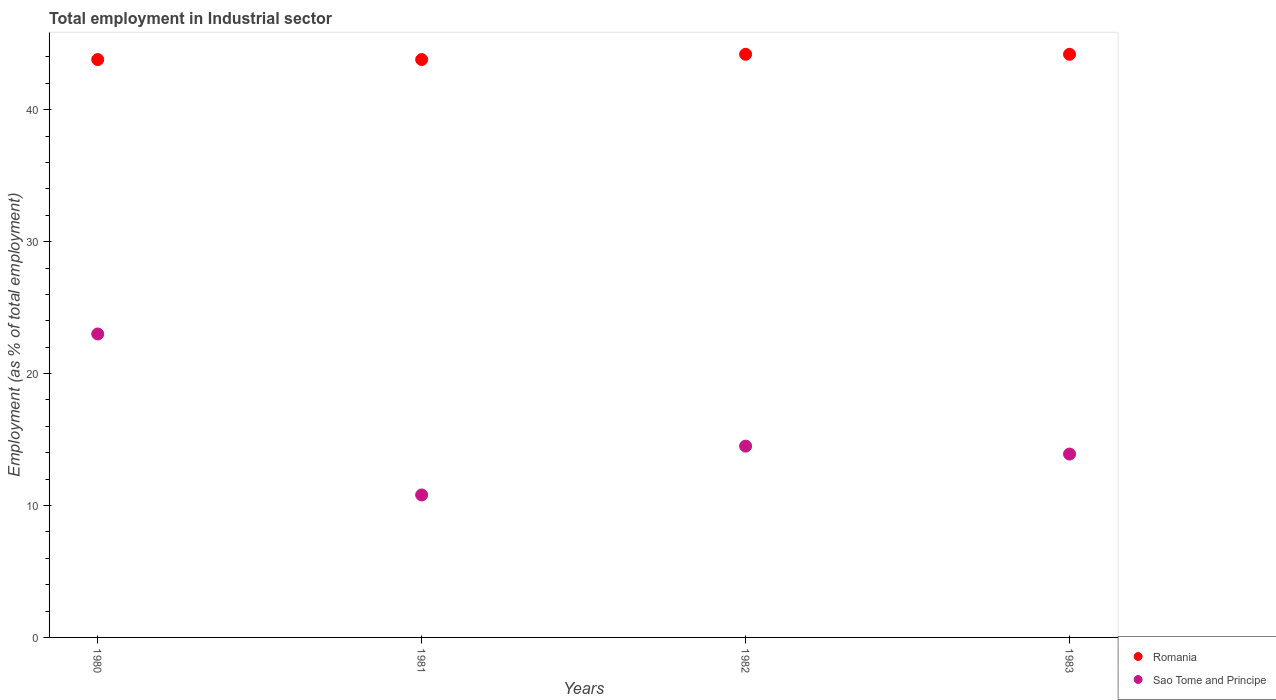Is the number of dotlines equal to the number of legend labels?
Ensure brevity in your answer.  Yes. What is the employment in industrial sector in Romania in 1983?
Provide a short and direct response. 44.2. Across all years, what is the maximum employment in industrial sector in Romania?
Your response must be concise. 44.2. Across all years, what is the minimum employment in industrial sector in Sao Tome and Principe?
Give a very brief answer. 10.8. In which year was the employment in industrial sector in Sao Tome and Principe minimum?
Offer a terse response. 1981. What is the total employment in industrial sector in Romania in the graph?
Your answer should be compact. 176. What is the difference between the employment in industrial sector in Romania in 1980 and that in 1981?
Provide a succinct answer. 0. What is the difference between the employment in industrial sector in Sao Tome and Principe in 1980 and the employment in industrial sector in Romania in 1982?
Provide a succinct answer. -21.2. What is the average employment in industrial sector in Romania per year?
Make the answer very short. 44. In the year 1983, what is the difference between the employment in industrial sector in Sao Tome and Principe and employment in industrial sector in Romania?
Provide a succinct answer. -30.3. In how many years, is the employment in industrial sector in Sao Tome and Principe greater than 8 %?
Provide a succinct answer. 4. What is the ratio of the employment in industrial sector in Romania in 1981 to that in 1983?
Your answer should be very brief. 0.99. What is the difference between the highest and the second highest employment in industrial sector in Romania?
Make the answer very short. 0. What is the difference between the highest and the lowest employment in industrial sector in Sao Tome and Principe?
Give a very brief answer. 12.2. In how many years, is the employment in industrial sector in Romania greater than the average employment in industrial sector in Romania taken over all years?
Provide a short and direct response. 2. Does the employment in industrial sector in Sao Tome and Principe monotonically increase over the years?
Ensure brevity in your answer.  No. Is the employment in industrial sector in Sao Tome and Principe strictly greater than the employment in industrial sector in Romania over the years?
Your answer should be very brief. No. How many years are there in the graph?
Your answer should be very brief. 4. Are the values on the major ticks of Y-axis written in scientific E-notation?
Keep it short and to the point. No. Does the graph contain grids?
Your answer should be very brief. No. How are the legend labels stacked?
Provide a short and direct response. Vertical. What is the title of the graph?
Your answer should be compact. Total employment in Industrial sector. Does "Europe(all income levels)" appear as one of the legend labels in the graph?
Ensure brevity in your answer.  No. What is the label or title of the Y-axis?
Give a very brief answer. Employment (as % of total employment). What is the Employment (as % of total employment) of Romania in 1980?
Keep it short and to the point. 43.8. What is the Employment (as % of total employment) in Sao Tome and Principe in 1980?
Give a very brief answer. 23. What is the Employment (as % of total employment) in Romania in 1981?
Your answer should be very brief. 43.8. What is the Employment (as % of total employment) in Sao Tome and Principe in 1981?
Make the answer very short. 10.8. What is the Employment (as % of total employment) of Romania in 1982?
Provide a succinct answer. 44.2. What is the Employment (as % of total employment) of Sao Tome and Principe in 1982?
Provide a succinct answer. 14.5. What is the Employment (as % of total employment) of Romania in 1983?
Your answer should be compact. 44.2. What is the Employment (as % of total employment) in Sao Tome and Principe in 1983?
Keep it short and to the point. 13.9. Across all years, what is the maximum Employment (as % of total employment) of Romania?
Provide a short and direct response. 44.2. Across all years, what is the minimum Employment (as % of total employment) in Romania?
Provide a short and direct response. 43.8. Across all years, what is the minimum Employment (as % of total employment) in Sao Tome and Principe?
Your answer should be compact. 10.8. What is the total Employment (as % of total employment) of Romania in the graph?
Your answer should be very brief. 176. What is the total Employment (as % of total employment) in Sao Tome and Principe in the graph?
Provide a short and direct response. 62.2. What is the difference between the Employment (as % of total employment) of Romania in 1980 and that in 1982?
Give a very brief answer. -0.4. What is the difference between the Employment (as % of total employment) of Sao Tome and Principe in 1980 and that in 1982?
Offer a terse response. 8.5. What is the difference between the Employment (as % of total employment) of Romania in 1980 and that in 1983?
Make the answer very short. -0.4. What is the difference between the Employment (as % of total employment) of Sao Tome and Principe in 1981 and that in 1983?
Provide a short and direct response. -3.1. What is the difference between the Employment (as % of total employment) in Romania in 1980 and the Employment (as % of total employment) in Sao Tome and Principe in 1981?
Provide a short and direct response. 33. What is the difference between the Employment (as % of total employment) in Romania in 1980 and the Employment (as % of total employment) in Sao Tome and Principe in 1982?
Provide a succinct answer. 29.3. What is the difference between the Employment (as % of total employment) of Romania in 1980 and the Employment (as % of total employment) of Sao Tome and Principe in 1983?
Provide a short and direct response. 29.9. What is the difference between the Employment (as % of total employment) of Romania in 1981 and the Employment (as % of total employment) of Sao Tome and Principe in 1982?
Offer a very short reply. 29.3. What is the difference between the Employment (as % of total employment) of Romania in 1981 and the Employment (as % of total employment) of Sao Tome and Principe in 1983?
Your answer should be very brief. 29.9. What is the difference between the Employment (as % of total employment) of Romania in 1982 and the Employment (as % of total employment) of Sao Tome and Principe in 1983?
Your answer should be compact. 30.3. What is the average Employment (as % of total employment) of Romania per year?
Keep it short and to the point. 44. What is the average Employment (as % of total employment) of Sao Tome and Principe per year?
Your answer should be very brief. 15.55. In the year 1980, what is the difference between the Employment (as % of total employment) in Romania and Employment (as % of total employment) in Sao Tome and Principe?
Offer a terse response. 20.8. In the year 1981, what is the difference between the Employment (as % of total employment) in Romania and Employment (as % of total employment) in Sao Tome and Principe?
Ensure brevity in your answer.  33. In the year 1982, what is the difference between the Employment (as % of total employment) in Romania and Employment (as % of total employment) in Sao Tome and Principe?
Offer a very short reply. 29.7. In the year 1983, what is the difference between the Employment (as % of total employment) of Romania and Employment (as % of total employment) of Sao Tome and Principe?
Offer a terse response. 30.3. What is the ratio of the Employment (as % of total employment) in Sao Tome and Principe in 1980 to that in 1981?
Offer a very short reply. 2.13. What is the ratio of the Employment (as % of total employment) of Sao Tome and Principe in 1980 to that in 1982?
Offer a terse response. 1.59. What is the ratio of the Employment (as % of total employment) in Romania in 1980 to that in 1983?
Provide a short and direct response. 0.99. What is the ratio of the Employment (as % of total employment) of Sao Tome and Principe in 1980 to that in 1983?
Provide a short and direct response. 1.65. What is the ratio of the Employment (as % of total employment) in Sao Tome and Principe in 1981 to that in 1982?
Provide a succinct answer. 0.74. What is the ratio of the Employment (as % of total employment) of Sao Tome and Principe in 1981 to that in 1983?
Ensure brevity in your answer.  0.78. What is the ratio of the Employment (as % of total employment) in Romania in 1982 to that in 1983?
Offer a terse response. 1. What is the ratio of the Employment (as % of total employment) in Sao Tome and Principe in 1982 to that in 1983?
Offer a very short reply. 1.04. 